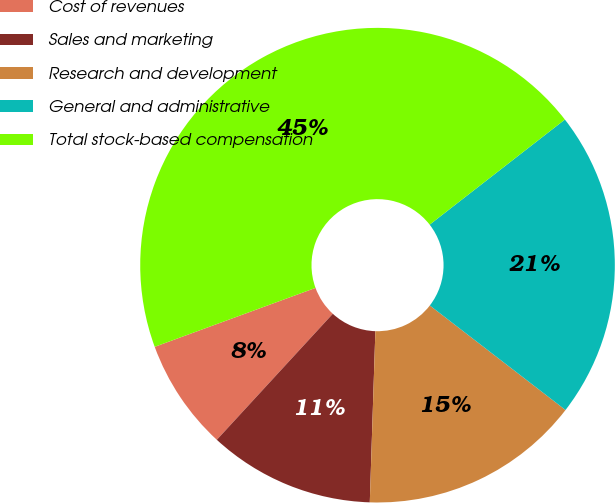Convert chart to OTSL. <chart><loc_0><loc_0><loc_500><loc_500><pie_chart><fcel>Cost of revenues<fcel>Sales and marketing<fcel>Research and development<fcel>General and administrative<fcel>Total stock-based compensation<nl><fcel>7.57%<fcel>11.32%<fcel>15.07%<fcel>20.96%<fcel>45.07%<nl></chart> 